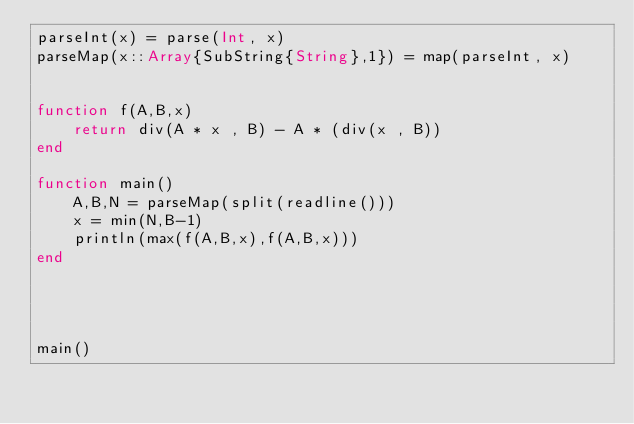Convert code to text. <code><loc_0><loc_0><loc_500><loc_500><_Julia_>parseInt(x) = parse(Int, x)
parseMap(x::Array{SubString{String},1}) = map(parseInt, x)


function f(A,B,x)
    return div(A * x , B) - A * (div(x , B))
end

function main()
    A,B,N = parseMap(split(readline()))
    x = min(N,B-1)
    println(max(f(A,B,x),f(A,B,x)))
end




main()</code> 